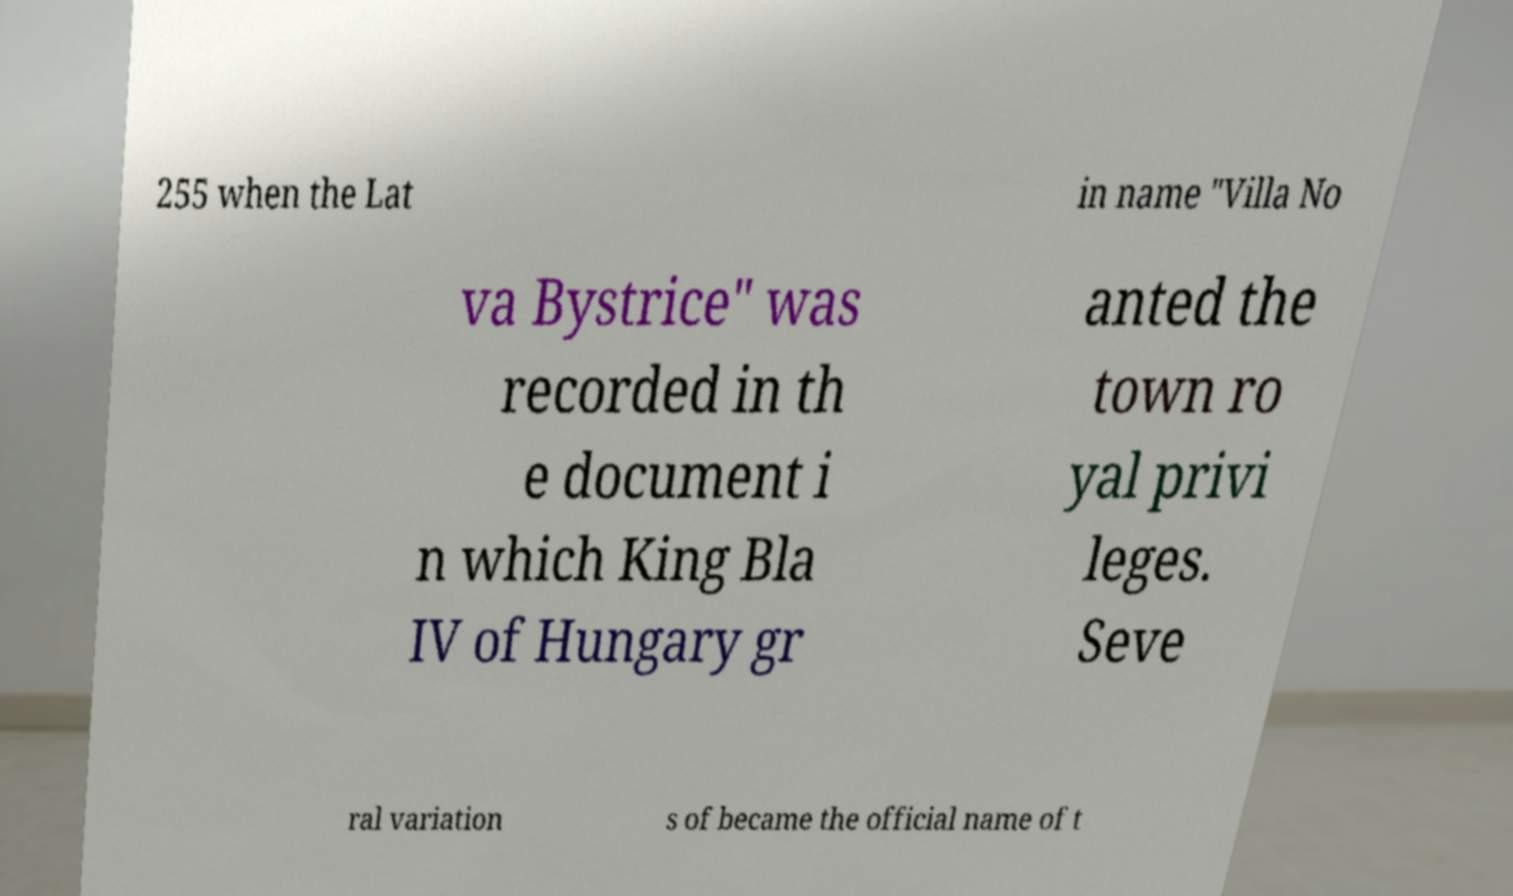Please identify and transcribe the text found in this image. 255 when the Lat in name "Villa No va Bystrice" was recorded in th e document i n which King Bla IV of Hungary gr anted the town ro yal privi leges. Seve ral variation s of became the official name of t 